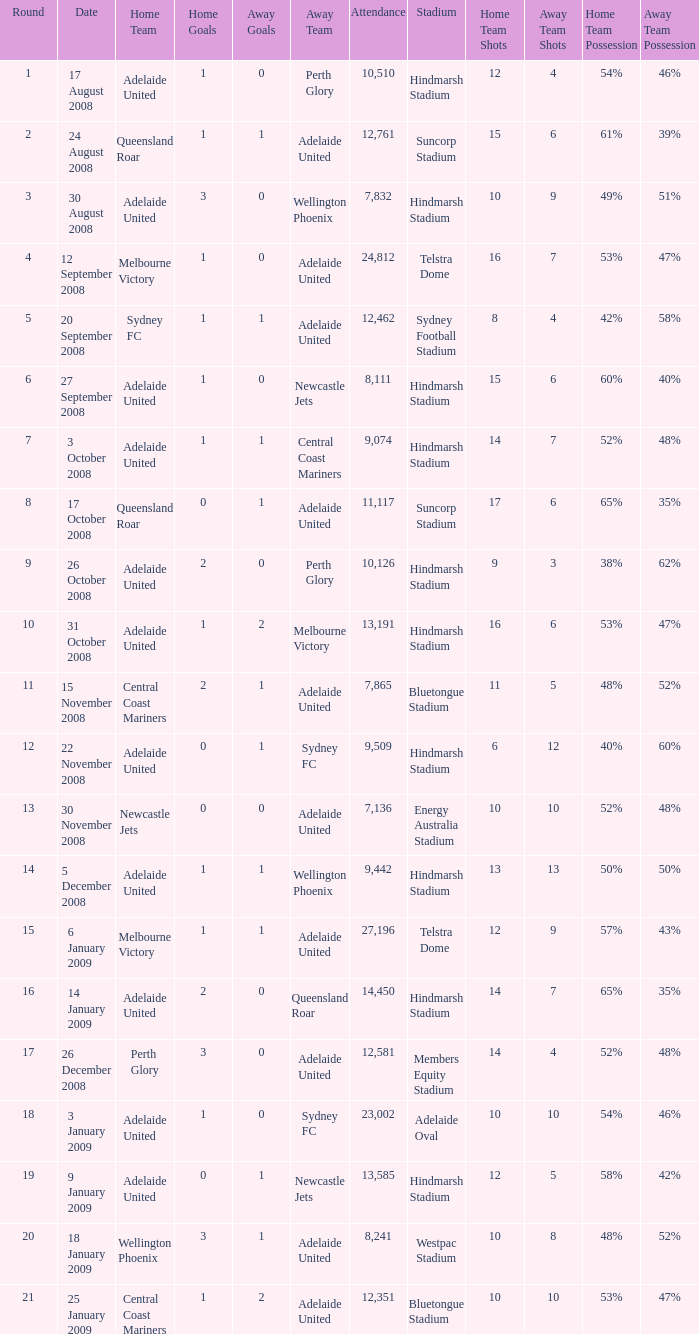What is the least round for the game played at Members Equity Stadium in from of 12,581 people? None. 